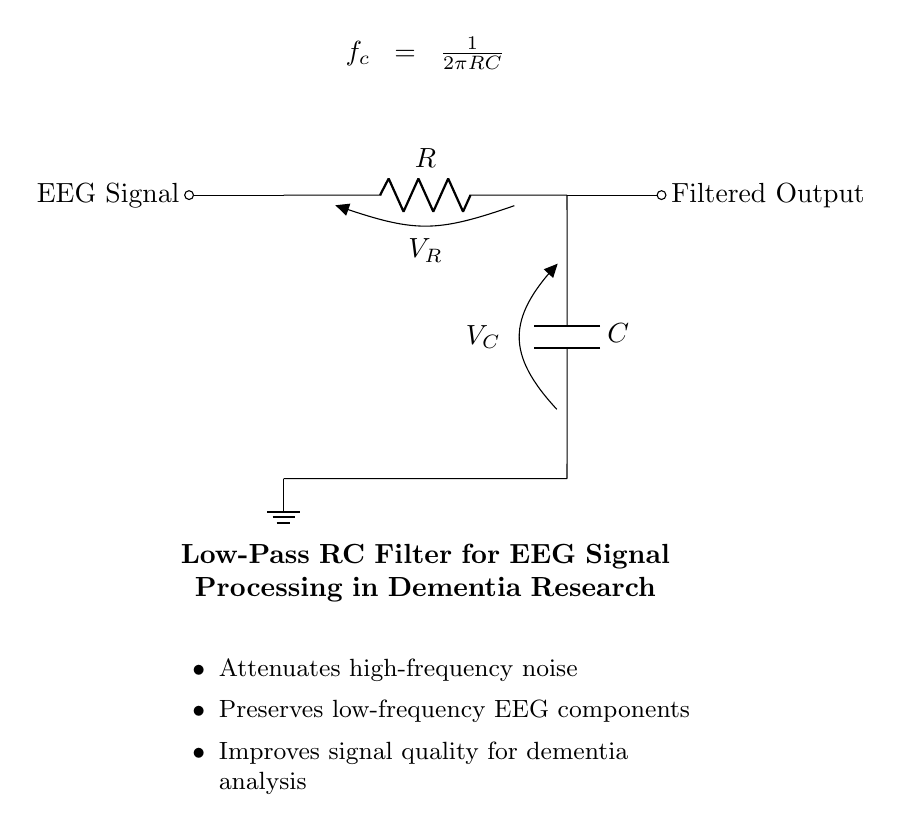What is the resistance value in this circuit? The resistance value is indicated in the diagram as 'R'. It can be any value determined by the researcher based on their specific needs in EEG signal processing.
Answer: R What does the capacitor do in this circuit? The capacitor, labeled 'C', stores charge and smooths the output signal by filtering out high-frequency noise while allowing low-frequency components to pass. This is essential for enhancing EEG signal quality.
Answer: Filter high-frequency noise What is the function of the low-pass filter in dementia research? The low-pass filter, created by the combination of the resistor and capacitor, helps to reduce high-frequency electrical noise and allows essential low-frequency EEG signal components to be observed more clearly, aiding in dementia analysis.
Answer: Reduces noise What is the equation for the cutoff frequency in the circuit? The equation for the cutoff frequency, which determines the point at which the filter attenuates higher frequencies, is given by 'f_c = 1/(2πRC)'. This relationship shows how R and C affect the filter's performance.
Answer: f_c = 1/(2πRC) How does changing the value of the capacitor affect the filter? Increasing the capacitance 'C' results in a lower cutoff frequency 'f_c', allowing more low-frequency signals to pass through while attenuating the higher frequencies more effectively. Conversely, decreasing 'C' raises the cutoff frequency.
Answer: Lowers cutoff frequency What is the significance of preserving low-frequency EEG components? Low-frequency EEG components are often critical for understanding brain function and disorders such as dementia. Preserving these signals allows researchers to analyze patterns and anomalies related to cognitive decline more effectively.
Answer: Essential for analysis 